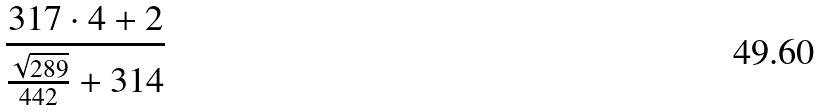Convert formula to latex. <formula><loc_0><loc_0><loc_500><loc_500>\frac { 3 1 7 \cdot 4 + 2 } { \frac { \sqrt { 2 8 9 } } { 4 4 2 } + 3 1 4 }</formula> 